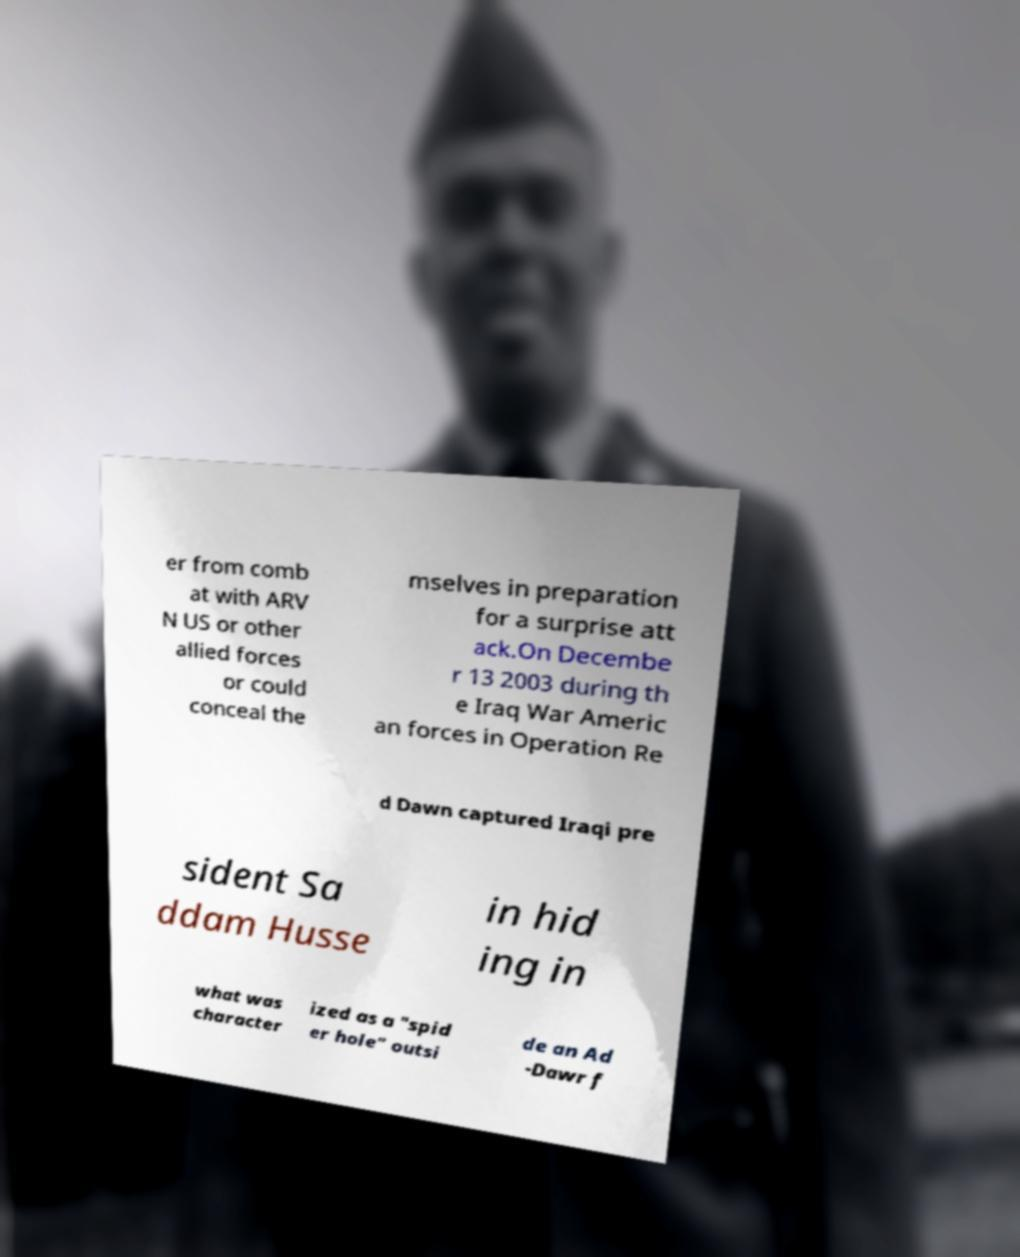Could you extract and type out the text from this image? er from comb at with ARV N US or other allied forces or could conceal the mselves in preparation for a surprise att ack.On Decembe r 13 2003 during th e Iraq War Americ an forces in Operation Re d Dawn captured Iraqi pre sident Sa ddam Husse in hid ing in what was character ized as a "spid er hole" outsi de an Ad -Dawr f 